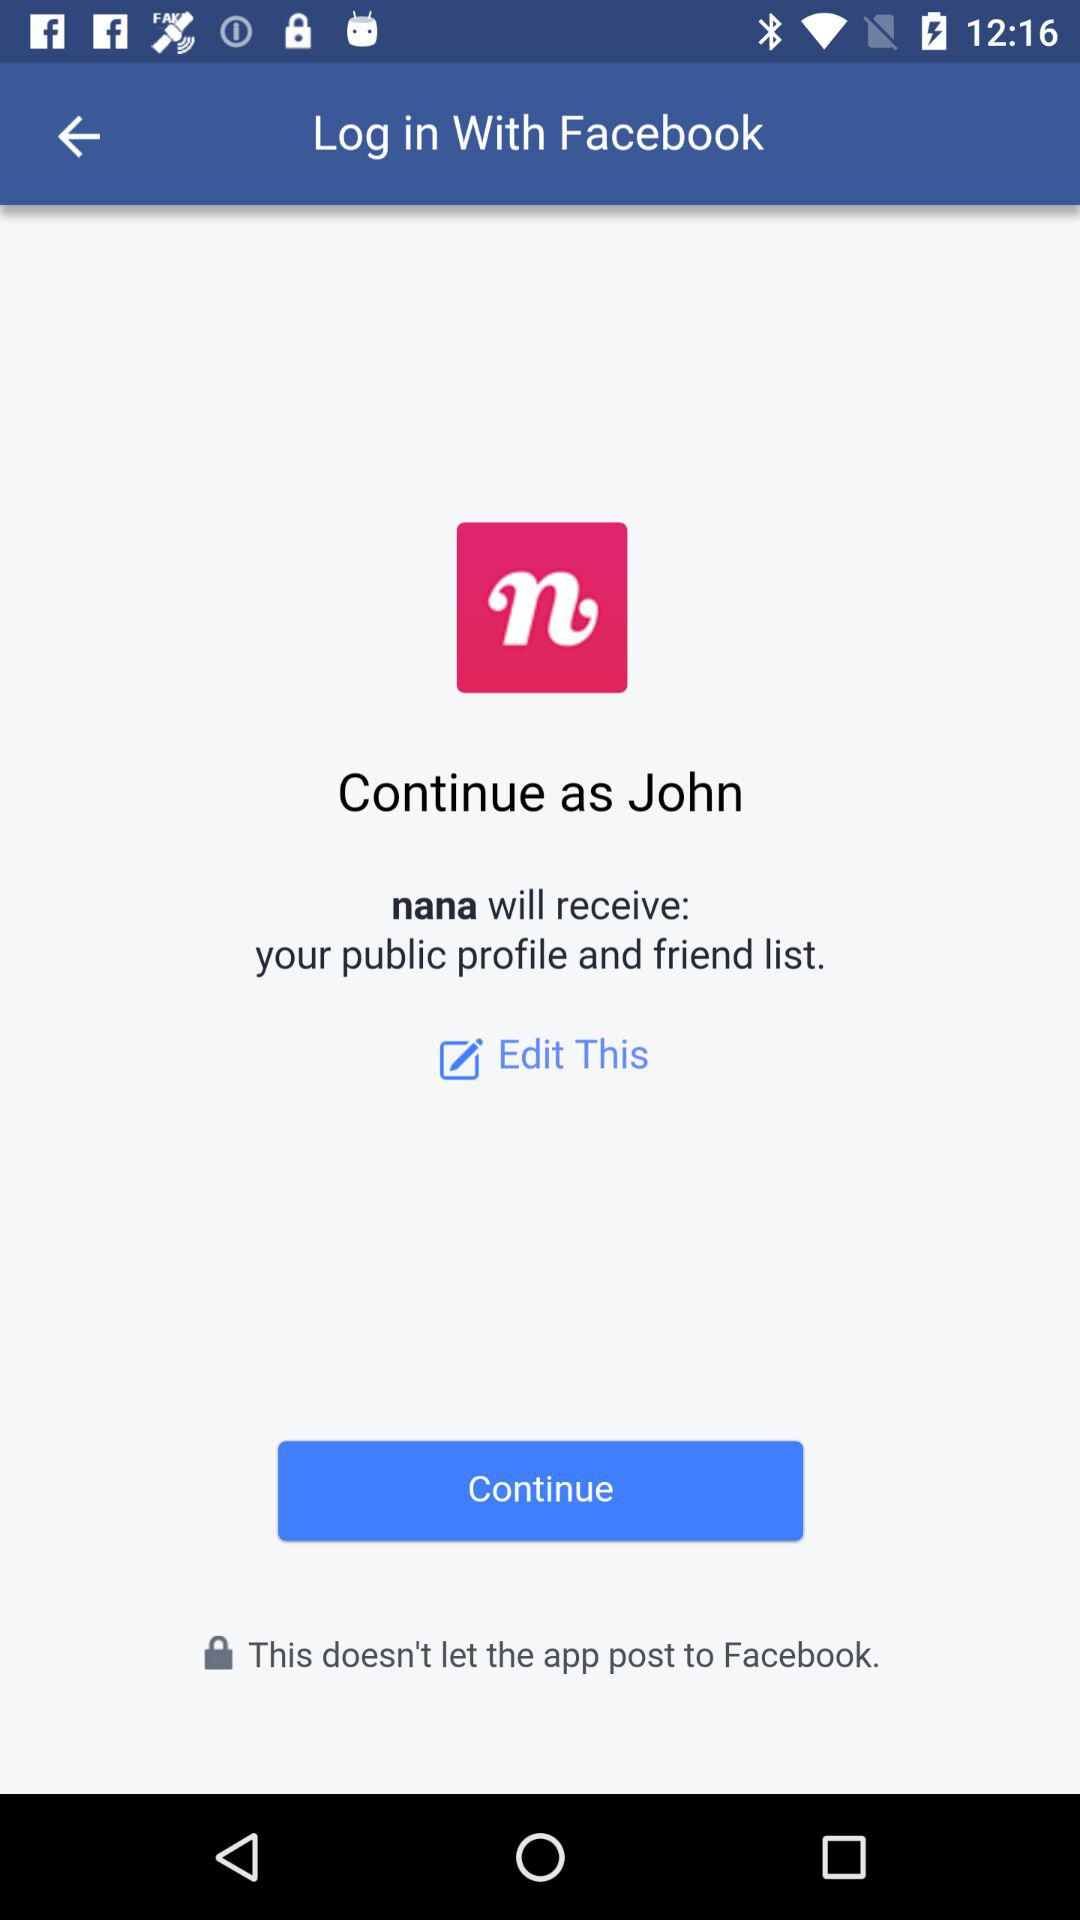How can we login? You can login with "Facebook". 